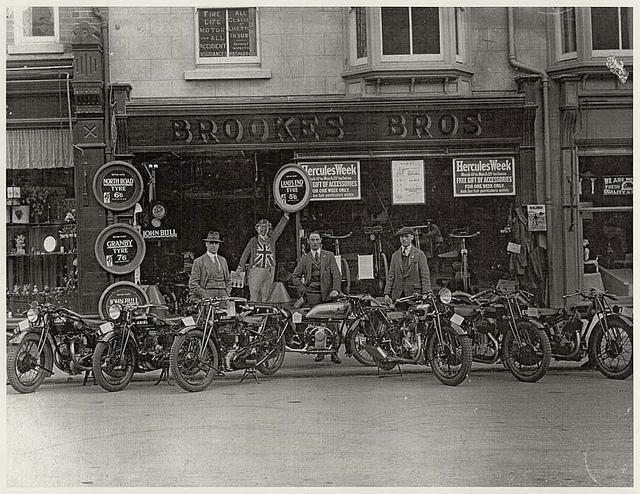How many people can you see?
Give a very brief answer. 3. How many motorcycles are there?
Give a very brief answer. 7. How many layers of bananas on this tree have been almost totally picked?
Give a very brief answer. 0. 